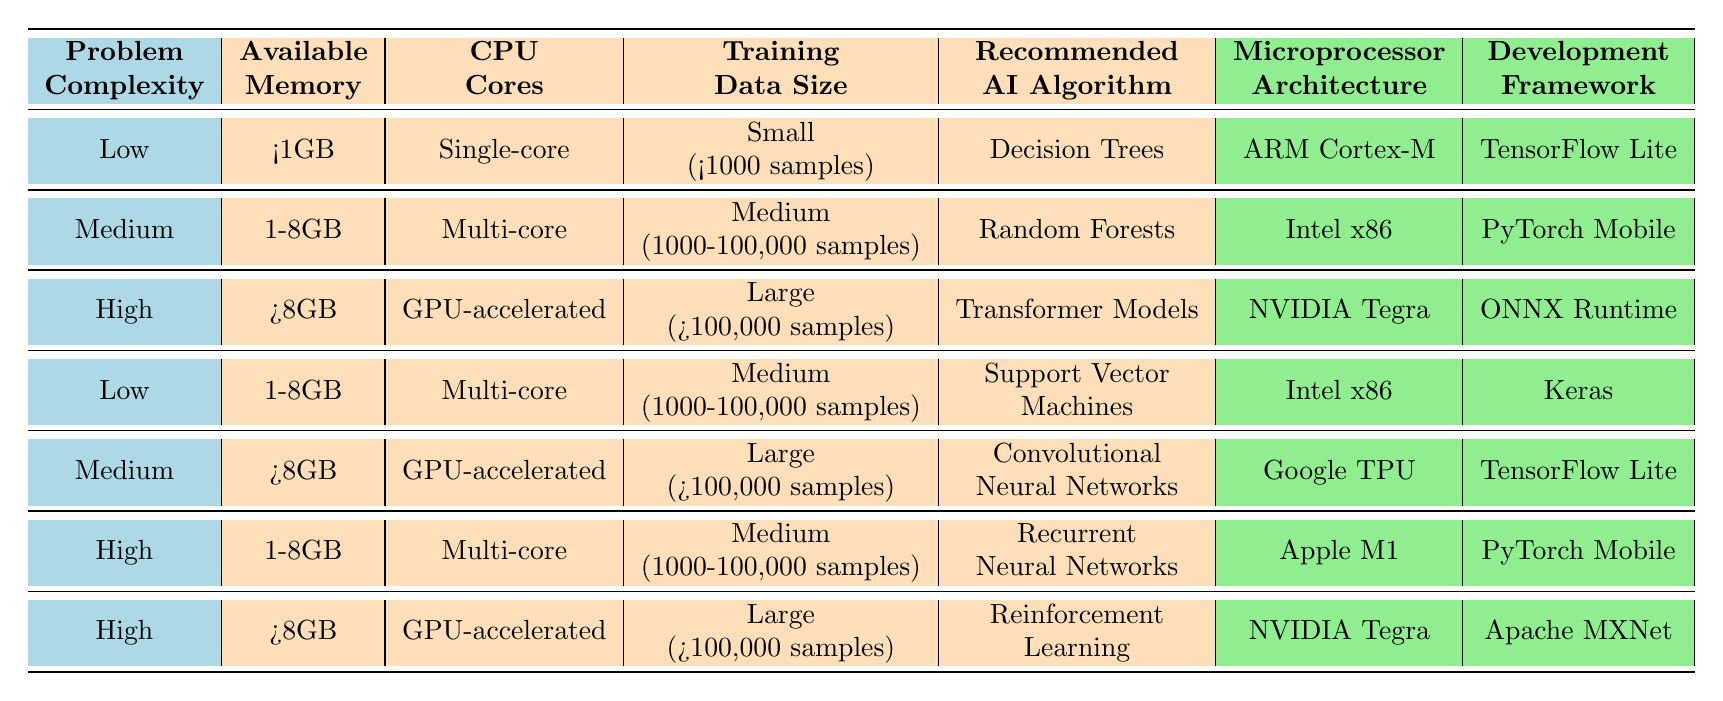What is the recommended AI algorithm when the problem complexity is High, available memory is >8GB? According to the table, for problem complexity High and available memory >8GB, we look for entries matching these criteria. The entry with High complexity and >8GB memory is Reinforcement Learning, which is recommended in this case.
Answer: Reinforcement Learning Is Support Vector Machines recommended for problems with Medium complexity and memory between 1-8GB? Looking through the table, Support Vector Machines are recommended for Low complexity with 1-8GB memory, but there are no recommendations for Medium complexity under this memory range. Therefore, the statement is false.
Answer: No How many AI algorithms are recommended for problems with Low complexity? The table lists Decision Trees for Low complexity with <1GB of memory, and Support Vector Machines for Low complexity with 1-8GB of memory. Counting these gives us 2 recommended algorithms for Low complexity problems.
Answer: 2 If you have a Medium complexity problem with large training data size (>100,000 samples) and >8GB of memory, which algorithm should you choose? Referring to the table, for Medium complexity, >8GB memory, and large training data size, the recommendation is Convolutional Neural Networks. This is found in the row corresponding to the combination of these conditions.
Answer: Convolutional Neural Networks True or False: Decision Trees are suitable for problems with High complexity and small training data size. The table shows that Decision Trees are only recommended for Low complexity problems and small training data. They are not suitable for High complexity problems according to the provided rules.
Answer: False What is the most resource-intensive AI algorithm recommended for training data size >100,000 samples? We look for the largest memory and processing power in the table. Reinforcement Learning is recommended for High complexity, >8GB memory, and large training size, indicating it requires substantial resources, more so than any other option listed.
Answer: Reinforcement Learning Which microprocessor architecture is recommended for Convolutional Neural Networks? Referring to the table, Convolutional Neural Networks are associated with Google TPU for Medium complexity, >8GB memory, and large training data size. Therefore, Google TPU is the microprocessor architecture recommended for this algorithm.
Answer: Google TPU How many entries in the table recommend using NVIDIA Tegra as the microprocessor architecture? From the table, we observe that NVIDIA Tegra is recommended for two algorithms: Transformer Models and Reinforcement Learning. Adding these gives us a total of 2 entries corresponding to NVIDIA Tegra.
Answer: 2 